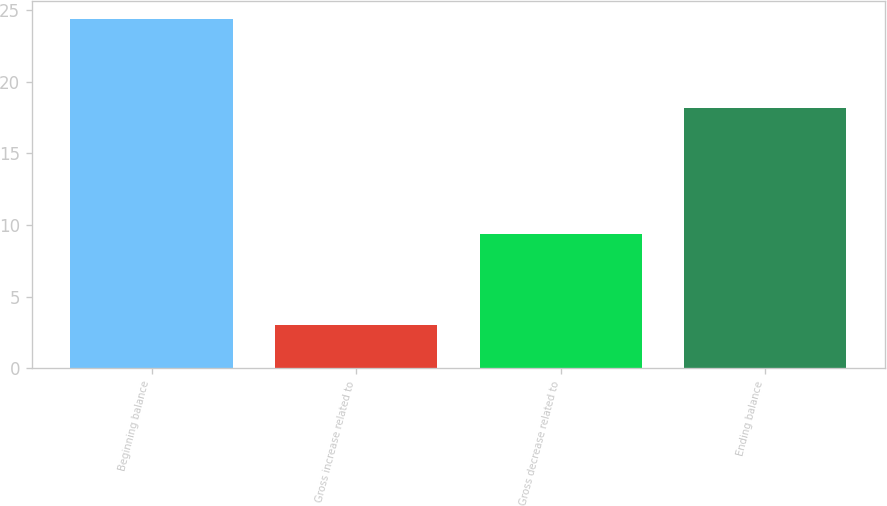<chart> <loc_0><loc_0><loc_500><loc_500><bar_chart><fcel>Beginning balance<fcel>Gross increase related to<fcel>Gross decrease related to<fcel>Ending balance<nl><fcel>24.4<fcel>2.98<fcel>9.4<fcel>18.2<nl></chart> 